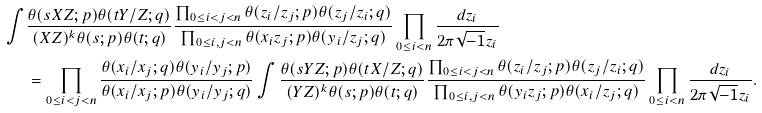Convert formula to latex. <formula><loc_0><loc_0><loc_500><loc_500>\int & \frac { \theta ( s X Z ; p ) \theta ( t Y / Z ; q ) } { ( X Z ) ^ { k } \theta ( s ; p ) \theta ( t ; q ) } \frac { \prod _ { 0 \leq i < j < n } \theta ( z _ { i } / z _ { j } ; p ) \theta ( z _ { j } / z _ { i } ; q ) } { \prod _ { 0 \leq i , j < n } \theta ( x _ { i } z _ { j } ; p ) \theta ( y _ { i } / z _ { j } ; q ) } \prod _ { 0 \leq i < n } \frac { d z _ { i } } { 2 \pi \sqrt { - 1 } z _ { i } } \\ & = \prod _ { 0 \leq i < j < n } \frac { \theta ( x _ { i } / x _ { j } ; q ) \theta ( y _ { i } / y _ { j } ; p ) } { \theta ( x _ { i } / x _ { j } ; p ) \theta ( y _ { i } / y _ { j } ; q ) } \int \frac { \theta ( s Y Z ; p ) \theta ( t X / Z ; q ) } { ( Y Z ) ^ { k } \theta ( s ; p ) \theta ( t ; q ) } \frac { \prod _ { 0 \leq i < j < n } \theta ( z _ { i } / z _ { j } ; p ) \theta ( z _ { j } / z _ { i } ; q ) } { \prod _ { 0 \leq i , j < n } \theta ( y _ { i } z _ { j } ; p ) \theta ( x _ { i } / z _ { j } ; q ) } \prod _ { 0 \leq i < n } \frac { d z _ { i } } { 2 \pi \sqrt { - 1 } z _ { i } } .</formula> 